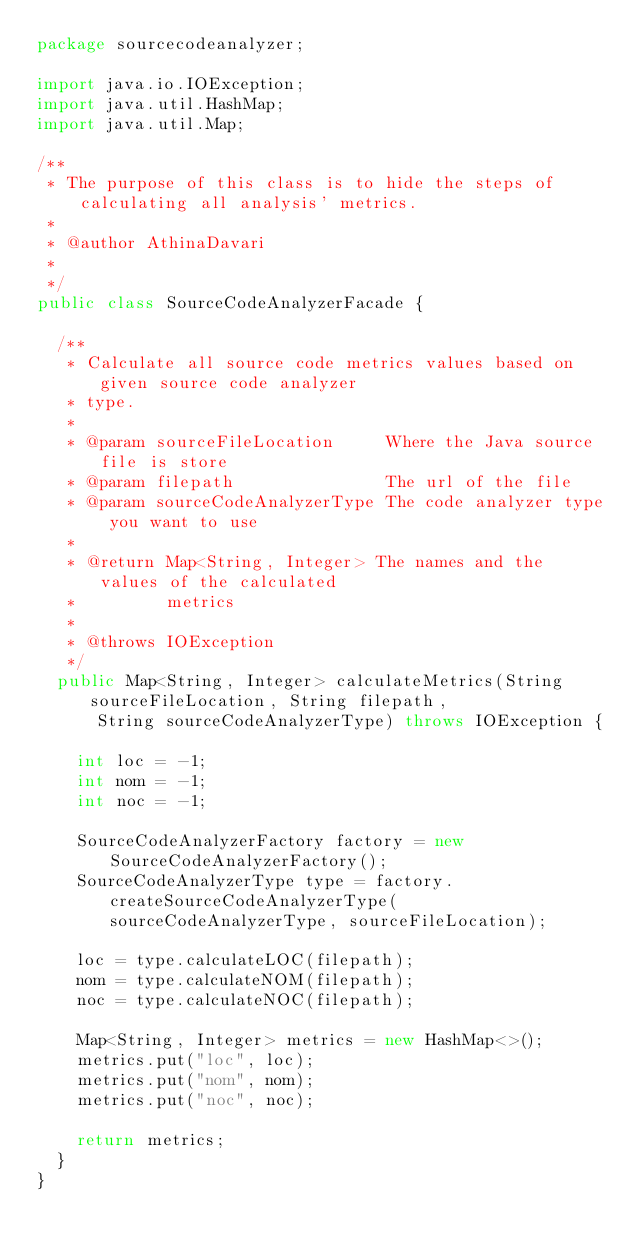<code> <loc_0><loc_0><loc_500><loc_500><_Java_>package sourcecodeanalyzer;

import java.io.IOException;
import java.util.HashMap;
import java.util.Map;

/**
 * The purpose of this class is to hide the steps of calculating all analysis' metrics.
 * 
 * @author AthinaDavari
 *
 */
public class SourceCodeAnalyzerFacade {

	/**
	 * Calculate all source code metrics values based on given source code analyzer
	 * type.
	 * 
	 * @param sourceFileLocation     Where the Java source file is store
	 * @param filepath               The url of the file
	 * @param sourceCodeAnalyzerType The code analyzer type you want to use
	 * 
	 * @return Map<String, Integer> The names and the values of the calculated
	 *         metrics
	 * 
	 * @throws IOException
	 */
	public Map<String, Integer> calculateMetrics(String sourceFileLocation, String filepath,
			String sourceCodeAnalyzerType) throws IOException {

		int loc = -1;
		int nom = -1;
		int noc = -1;

		SourceCodeAnalyzerFactory factory = new SourceCodeAnalyzerFactory();
		SourceCodeAnalyzerType type = factory.createSourceCodeAnalyzerType(sourceCodeAnalyzerType, sourceFileLocation);

		loc = type.calculateLOC(filepath);
		nom = type.calculateNOM(filepath);
		noc = type.calculateNOC(filepath);

		Map<String, Integer> metrics = new HashMap<>();
		metrics.put("loc", loc);
		metrics.put("nom", nom);
		metrics.put("noc", noc);

		return metrics;
	}
}
</code> 